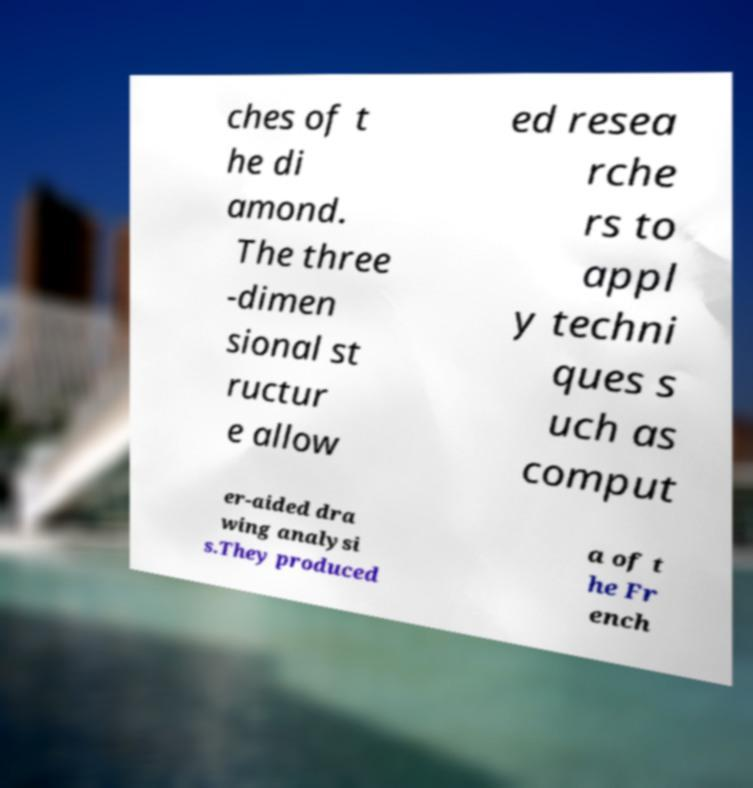Can you accurately transcribe the text from the provided image for me? ches of t he di amond. The three -dimen sional st ructur e allow ed resea rche rs to appl y techni ques s uch as comput er-aided dra wing analysi s.They produced a of t he Fr ench 